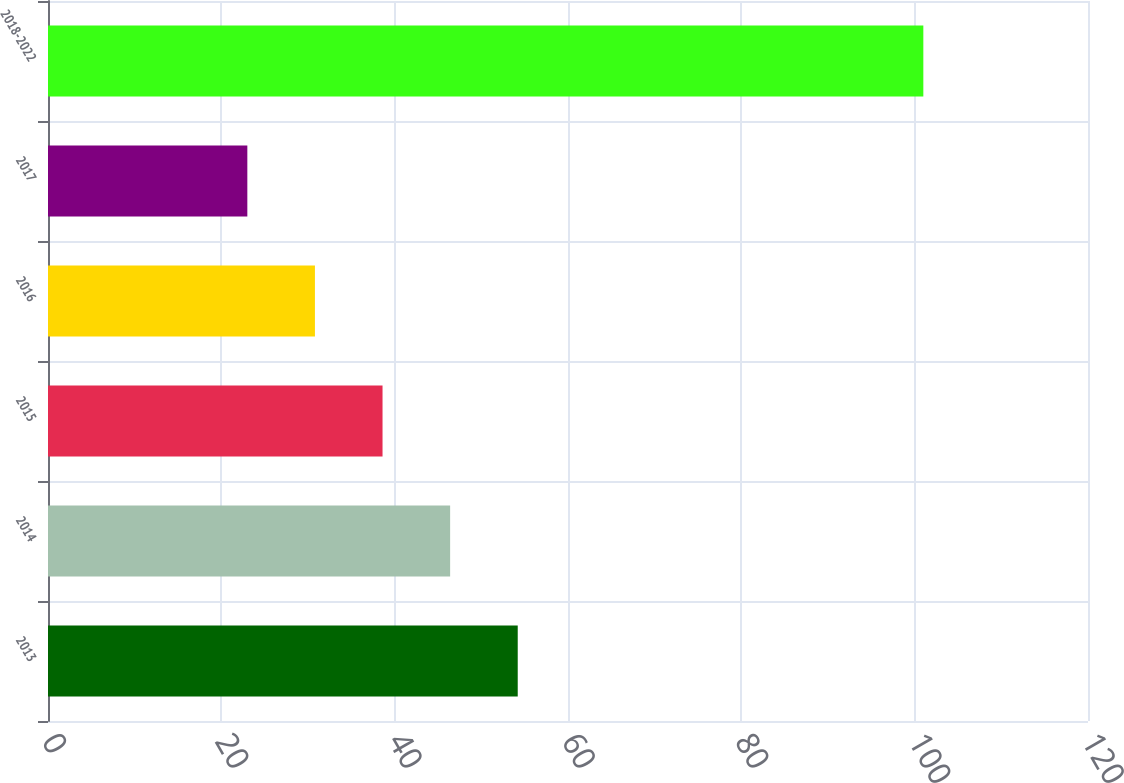Convert chart to OTSL. <chart><loc_0><loc_0><loc_500><loc_500><bar_chart><fcel>2013<fcel>2014<fcel>2015<fcel>2016<fcel>2017<fcel>2018-2022<nl><fcel>54.2<fcel>46.4<fcel>38.6<fcel>30.8<fcel>23<fcel>101<nl></chart> 